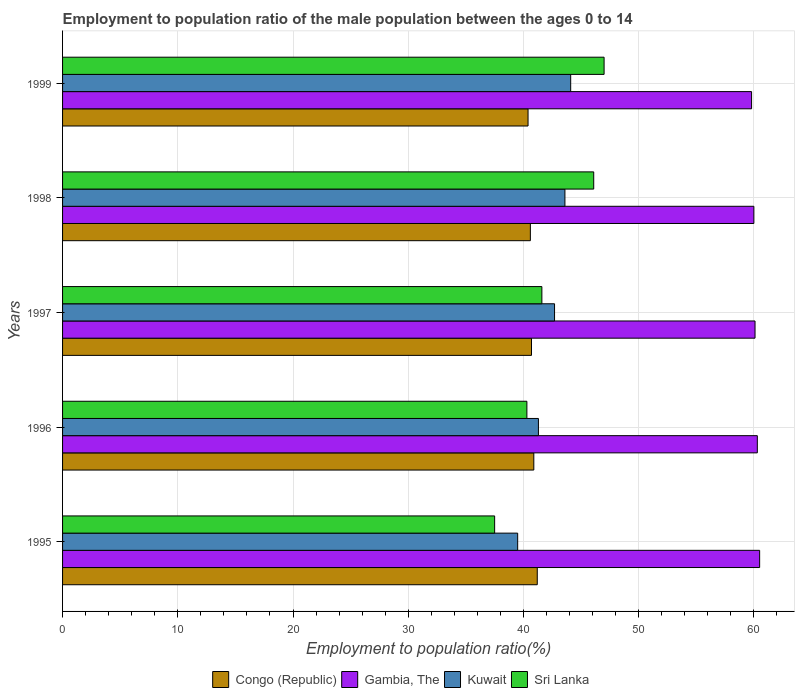How many different coloured bars are there?
Provide a succinct answer. 4. How many groups of bars are there?
Your answer should be very brief. 5. Are the number of bars per tick equal to the number of legend labels?
Your answer should be compact. Yes. Are the number of bars on each tick of the Y-axis equal?
Keep it short and to the point. Yes. How many bars are there on the 5th tick from the bottom?
Offer a very short reply. 4. What is the employment to population ratio in Congo (Republic) in 1998?
Your answer should be compact. 40.6. Across all years, what is the maximum employment to population ratio in Congo (Republic)?
Provide a succinct answer. 41.2. Across all years, what is the minimum employment to population ratio in Congo (Republic)?
Give a very brief answer. 40.4. In which year was the employment to population ratio in Sri Lanka maximum?
Keep it short and to the point. 1999. What is the total employment to population ratio in Kuwait in the graph?
Offer a very short reply. 211.2. What is the difference between the employment to population ratio in Kuwait in 1998 and the employment to population ratio in Congo (Republic) in 1995?
Your answer should be very brief. 2.4. What is the average employment to population ratio in Gambia, The per year?
Offer a very short reply. 60.14. In the year 1996, what is the difference between the employment to population ratio in Congo (Republic) and employment to population ratio in Sri Lanka?
Provide a succinct answer. 0.6. In how many years, is the employment to population ratio in Sri Lanka greater than 16 %?
Make the answer very short. 5. What is the ratio of the employment to population ratio in Sri Lanka in 1995 to that in 1996?
Your answer should be very brief. 0.93. Is the employment to population ratio in Sri Lanka in 1997 less than that in 1998?
Your answer should be compact. Yes. What is the difference between the highest and the second highest employment to population ratio in Congo (Republic)?
Offer a terse response. 0.3. What does the 4th bar from the top in 1995 represents?
Your answer should be compact. Congo (Republic). What does the 3rd bar from the bottom in 1996 represents?
Give a very brief answer. Kuwait. Is it the case that in every year, the sum of the employment to population ratio in Congo (Republic) and employment to population ratio in Gambia, The is greater than the employment to population ratio in Kuwait?
Provide a succinct answer. Yes. How many bars are there?
Offer a terse response. 20. What is the difference between two consecutive major ticks on the X-axis?
Offer a very short reply. 10. Are the values on the major ticks of X-axis written in scientific E-notation?
Give a very brief answer. No. Does the graph contain grids?
Offer a very short reply. Yes. Where does the legend appear in the graph?
Your answer should be compact. Bottom center. What is the title of the graph?
Your answer should be compact. Employment to population ratio of the male population between the ages 0 to 14. What is the label or title of the X-axis?
Ensure brevity in your answer.  Employment to population ratio(%). What is the Employment to population ratio(%) of Congo (Republic) in 1995?
Ensure brevity in your answer.  41.2. What is the Employment to population ratio(%) in Gambia, The in 1995?
Your response must be concise. 60.5. What is the Employment to population ratio(%) in Kuwait in 1995?
Offer a terse response. 39.5. What is the Employment to population ratio(%) in Sri Lanka in 1995?
Your response must be concise. 37.5. What is the Employment to population ratio(%) in Congo (Republic) in 1996?
Your response must be concise. 40.9. What is the Employment to population ratio(%) of Gambia, The in 1996?
Your answer should be compact. 60.3. What is the Employment to population ratio(%) of Kuwait in 1996?
Offer a terse response. 41.3. What is the Employment to population ratio(%) of Sri Lanka in 1996?
Offer a terse response. 40.3. What is the Employment to population ratio(%) of Congo (Republic) in 1997?
Offer a very short reply. 40.7. What is the Employment to population ratio(%) of Gambia, The in 1997?
Your answer should be very brief. 60.1. What is the Employment to population ratio(%) in Kuwait in 1997?
Offer a terse response. 42.7. What is the Employment to population ratio(%) in Sri Lanka in 1997?
Your response must be concise. 41.6. What is the Employment to population ratio(%) of Congo (Republic) in 1998?
Offer a very short reply. 40.6. What is the Employment to population ratio(%) in Kuwait in 1998?
Make the answer very short. 43.6. What is the Employment to population ratio(%) in Sri Lanka in 1998?
Your answer should be very brief. 46.1. What is the Employment to population ratio(%) of Congo (Republic) in 1999?
Your answer should be very brief. 40.4. What is the Employment to population ratio(%) in Gambia, The in 1999?
Your answer should be very brief. 59.8. What is the Employment to population ratio(%) in Kuwait in 1999?
Your answer should be very brief. 44.1. Across all years, what is the maximum Employment to population ratio(%) in Congo (Republic)?
Your answer should be very brief. 41.2. Across all years, what is the maximum Employment to population ratio(%) of Gambia, The?
Give a very brief answer. 60.5. Across all years, what is the maximum Employment to population ratio(%) of Kuwait?
Your answer should be very brief. 44.1. Across all years, what is the minimum Employment to population ratio(%) of Congo (Republic)?
Keep it short and to the point. 40.4. Across all years, what is the minimum Employment to population ratio(%) in Gambia, The?
Provide a succinct answer. 59.8. Across all years, what is the minimum Employment to population ratio(%) in Kuwait?
Offer a very short reply. 39.5. Across all years, what is the minimum Employment to population ratio(%) in Sri Lanka?
Your response must be concise. 37.5. What is the total Employment to population ratio(%) of Congo (Republic) in the graph?
Your answer should be compact. 203.8. What is the total Employment to population ratio(%) of Gambia, The in the graph?
Offer a terse response. 300.7. What is the total Employment to population ratio(%) of Kuwait in the graph?
Give a very brief answer. 211.2. What is the total Employment to population ratio(%) of Sri Lanka in the graph?
Give a very brief answer. 212.5. What is the difference between the Employment to population ratio(%) in Gambia, The in 1995 and that in 1996?
Ensure brevity in your answer.  0.2. What is the difference between the Employment to population ratio(%) in Kuwait in 1995 and that in 1996?
Make the answer very short. -1.8. What is the difference between the Employment to population ratio(%) of Congo (Republic) in 1995 and that in 1997?
Your answer should be very brief. 0.5. What is the difference between the Employment to population ratio(%) of Kuwait in 1995 and that in 1997?
Offer a terse response. -3.2. What is the difference between the Employment to population ratio(%) in Congo (Republic) in 1995 and that in 1998?
Your answer should be compact. 0.6. What is the difference between the Employment to population ratio(%) of Sri Lanka in 1995 and that in 1999?
Provide a short and direct response. -9.5. What is the difference between the Employment to population ratio(%) of Congo (Republic) in 1996 and that in 1997?
Your answer should be compact. 0.2. What is the difference between the Employment to population ratio(%) in Sri Lanka in 1996 and that in 1997?
Make the answer very short. -1.3. What is the difference between the Employment to population ratio(%) of Congo (Republic) in 1996 and that in 1998?
Provide a succinct answer. 0.3. What is the difference between the Employment to population ratio(%) of Sri Lanka in 1996 and that in 1998?
Offer a terse response. -5.8. What is the difference between the Employment to population ratio(%) in Congo (Republic) in 1996 and that in 1999?
Offer a very short reply. 0.5. What is the difference between the Employment to population ratio(%) of Gambia, The in 1996 and that in 1999?
Your answer should be very brief. 0.5. What is the difference between the Employment to population ratio(%) in Kuwait in 1996 and that in 1999?
Provide a succinct answer. -2.8. What is the difference between the Employment to population ratio(%) of Sri Lanka in 1996 and that in 1999?
Make the answer very short. -6.7. What is the difference between the Employment to population ratio(%) of Kuwait in 1997 and that in 1998?
Your response must be concise. -0.9. What is the difference between the Employment to population ratio(%) in Gambia, The in 1997 and that in 1999?
Provide a succinct answer. 0.3. What is the difference between the Employment to population ratio(%) in Kuwait in 1997 and that in 1999?
Ensure brevity in your answer.  -1.4. What is the difference between the Employment to population ratio(%) of Congo (Republic) in 1998 and that in 1999?
Ensure brevity in your answer.  0.2. What is the difference between the Employment to population ratio(%) of Sri Lanka in 1998 and that in 1999?
Provide a short and direct response. -0.9. What is the difference between the Employment to population ratio(%) of Congo (Republic) in 1995 and the Employment to population ratio(%) of Gambia, The in 1996?
Your answer should be compact. -19.1. What is the difference between the Employment to population ratio(%) in Congo (Republic) in 1995 and the Employment to population ratio(%) in Kuwait in 1996?
Ensure brevity in your answer.  -0.1. What is the difference between the Employment to population ratio(%) of Gambia, The in 1995 and the Employment to population ratio(%) of Sri Lanka in 1996?
Your answer should be very brief. 20.2. What is the difference between the Employment to population ratio(%) in Kuwait in 1995 and the Employment to population ratio(%) in Sri Lanka in 1996?
Give a very brief answer. -0.8. What is the difference between the Employment to population ratio(%) in Congo (Republic) in 1995 and the Employment to population ratio(%) in Gambia, The in 1997?
Your answer should be compact. -18.9. What is the difference between the Employment to population ratio(%) of Congo (Republic) in 1995 and the Employment to population ratio(%) of Kuwait in 1997?
Make the answer very short. -1.5. What is the difference between the Employment to population ratio(%) of Congo (Republic) in 1995 and the Employment to population ratio(%) of Sri Lanka in 1997?
Give a very brief answer. -0.4. What is the difference between the Employment to population ratio(%) in Gambia, The in 1995 and the Employment to population ratio(%) in Kuwait in 1997?
Offer a terse response. 17.8. What is the difference between the Employment to population ratio(%) in Congo (Republic) in 1995 and the Employment to population ratio(%) in Gambia, The in 1998?
Provide a succinct answer. -18.8. What is the difference between the Employment to population ratio(%) of Congo (Republic) in 1995 and the Employment to population ratio(%) of Sri Lanka in 1998?
Provide a short and direct response. -4.9. What is the difference between the Employment to population ratio(%) in Kuwait in 1995 and the Employment to population ratio(%) in Sri Lanka in 1998?
Provide a succinct answer. -6.6. What is the difference between the Employment to population ratio(%) in Congo (Republic) in 1995 and the Employment to population ratio(%) in Gambia, The in 1999?
Offer a very short reply. -18.6. What is the difference between the Employment to population ratio(%) in Congo (Republic) in 1996 and the Employment to population ratio(%) in Gambia, The in 1997?
Keep it short and to the point. -19.2. What is the difference between the Employment to population ratio(%) in Congo (Republic) in 1996 and the Employment to population ratio(%) in Gambia, The in 1998?
Keep it short and to the point. -19.1. What is the difference between the Employment to population ratio(%) in Congo (Republic) in 1996 and the Employment to population ratio(%) in Kuwait in 1998?
Your response must be concise. -2.7. What is the difference between the Employment to population ratio(%) in Congo (Republic) in 1996 and the Employment to population ratio(%) in Sri Lanka in 1998?
Your response must be concise. -5.2. What is the difference between the Employment to population ratio(%) in Gambia, The in 1996 and the Employment to population ratio(%) in Kuwait in 1998?
Keep it short and to the point. 16.7. What is the difference between the Employment to population ratio(%) of Congo (Republic) in 1996 and the Employment to population ratio(%) of Gambia, The in 1999?
Offer a very short reply. -18.9. What is the difference between the Employment to population ratio(%) of Congo (Republic) in 1996 and the Employment to population ratio(%) of Kuwait in 1999?
Provide a succinct answer. -3.2. What is the difference between the Employment to population ratio(%) in Congo (Republic) in 1996 and the Employment to population ratio(%) in Sri Lanka in 1999?
Make the answer very short. -6.1. What is the difference between the Employment to population ratio(%) of Congo (Republic) in 1997 and the Employment to population ratio(%) of Gambia, The in 1998?
Give a very brief answer. -19.3. What is the difference between the Employment to population ratio(%) in Congo (Republic) in 1997 and the Employment to population ratio(%) in Kuwait in 1998?
Your response must be concise. -2.9. What is the difference between the Employment to population ratio(%) of Congo (Republic) in 1997 and the Employment to population ratio(%) of Sri Lanka in 1998?
Your response must be concise. -5.4. What is the difference between the Employment to population ratio(%) in Congo (Republic) in 1997 and the Employment to population ratio(%) in Gambia, The in 1999?
Make the answer very short. -19.1. What is the difference between the Employment to population ratio(%) of Gambia, The in 1997 and the Employment to population ratio(%) of Kuwait in 1999?
Provide a succinct answer. 16. What is the difference between the Employment to population ratio(%) in Gambia, The in 1997 and the Employment to population ratio(%) in Sri Lanka in 1999?
Provide a short and direct response. 13.1. What is the difference between the Employment to population ratio(%) in Congo (Republic) in 1998 and the Employment to population ratio(%) in Gambia, The in 1999?
Give a very brief answer. -19.2. What is the difference between the Employment to population ratio(%) of Kuwait in 1998 and the Employment to population ratio(%) of Sri Lanka in 1999?
Offer a very short reply. -3.4. What is the average Employment to population ratio(%) of Congo (Republic) per year?
Give a very brief answer. 40.76. What is the average Employment to population ratio(%) of Gambia, The per year?
Ensure brevity in your answer.  60.14. What is the average Employment to population ratio(%) in Kuwait per year?
Ensure brevity in your answer.  42.24. What is the average Employment to population ratio(%) of Sri Lanka per year?
Ensure brevity in your answer.  42.5. In the year 1995, what is the difference between the Employment to population ratio(%) in Congo (Republic) and Employment to population ratio(%) in Gambia, The?
Your answer should be very brief. -19.3. In the year 1995, what is the difference between the Employment to population ratio(%) in Congo (Republic) and Employment to population ratio(%) in Kuwait?
Provide a short and direct response. 1.7. In the year 1995, what is the difference between the Employment to population ratio(%) in Kuwait and Employment to population ratio(%) in Sri Lanka?
Your answer should be compact. 2. In the year 1996, what is the difference between the Employment to population ratio(%) in Congo (Republic) and Employment to population ratio(%) in Gambia, The?
Keep it short and to the point. -19.4. In the year 1996, what is the difference between the Employment to population ratio(%) in Congo (Republic) and Employment to population ratio(%) in Kuwait?
Your answer should be very brief. -0.4. In the year 1996, what is the difference between the Employment to population ratio(%) of Gambia, The and Employment to population ratio(%) of Kuwait?
Offer a very short reply. 19. In the year 1996, what is the difference between the Employment to population ratio(%) of Gambia, The and Employment to population ratio(%) of Sri Lanka?
Make the answer very short. 20. In the year 1996, what is the difference between the Employment to population ratio(%) of Kuwait and Employment to population ratio(%) of Sri Lanka?
Offer a terse response. 1. In the year 1997, what is the difference between the Employment to population ratio(%) of Congo (Republic) and Employment to population ratio(%) of Gambia, The?
Your answer should be very brief. -19.4. In the year 1997, what is the difference between the Employment to population ratio(%) of Congo (Republic) and Employment to population ratio(%) of Sri Lanka?
Offer a very short reply. -0.9. In the year 1997, what is the difference between the Employment to population ratio(%) in Gambia, The and Employment to population ratio(%) in Kuwait?
Your answer should be very brief. 17.4. In the year 1997, what is the difference between the Employment to population ratio(%) in Gambia, The and Employment to population ratio(%) in Sri Lanka?
Offer a terse response. 18.5. In the year 1997, what is the difference between the Employment to population ratio(%) in Kuwait and Employment to population ratio(%) in Sri Lanka?
Offer a very short reply. 1.1. In the year 1998, what is the difference between the Employment to population ratio(%) in Congo (Republic) and Employment to population ratio(%) in Gambia, The?
Offer a very short reply. -19.4. In the year 1998, what is the difference between the Employment to population ratio(%) in Gambia, The and Employment to population ratio(%) in Sri Lanka?
Offer a terse response. 13.9. In the year 1998, what is the difference between the Employment to population ratio(%) in Kuwait and Employment to population ratio(%) in Sri Lanka?
Offer a very short reply. -2.5. In the year 1999, what is the difference between the Employment to population ratio(%) in Congo (Republic) and Employment to population ratio(%) in Gambia, The?
Offer a very short reply. -19.4. In the year 1999, what is the difference between the Employment to population ratio(%) of Congo (Republic) and Employment to population ratio(%) of Sri Lanka?
Your response must be concise. -6.6. In the year 1999, what is the difference between the Employment to population ratio(%) of Gambia, The and Employment to population ratio(%) of Kuwait?
Offer a terse response. 15.7. What is the ratio of the Employment to population ratio(%) in Congo (Republic) in 1995 to that in 1996?
Keep it short and to the point. 1.01. What is the ratio of the Employment to population ratio(%) of Gambia, The in 1995 to that in 1996?
Make the answer very short. 1. What is the ratio of the Employment to population ratio(%) in Kuwait in 1995 to that in 1996?
Your answer should be very brief. 0.96. What is the ratio of the Employment to population ratio(%) of Sri Lanka in 1995 to that in 1996?
Provide a succinct answer. 0.93. What is the ratio of the Employment to population ratio(%) of Congo (Republic) in 1995 to that in 1997?
Your answer should be compact. 1.01. What is the ratio of the Employment to population ratio(%) of Gambia, The in 1995 to that in 1997?
Ensure brevity in your answer.  1.01. What is the ratio of the Employment to population ratio(%) in Kuwait in 1995 to that in 1997?
Provide a succinct answer. 0.93. What is the ratio of the Employment to population ratio(%) in Sri Lanka in 1995 to that in 1997?
Your answer should be very brief. 0.9. What is the ratio of the Employment to population ratio(%) of Congo (Republic) in 1995 to that in 1998?
Offer a terse response. 1.01. What is the ratio of the Employment to population ratio(%) in Gambia, The in 1995 to that in 1998?
Provide a short and direct response. 1.01. What is the ratio of the Employment to population ratio(%) in Kuwait in 1995 to that in 1998?
Provide a short and direct response. 0.91. What is the ratio of the Employment to population ratio(%) in Sri Lanka in 1995 to that in 1998?
Your answer should be compact. 0.81. What is the ratio of the Employment to population ratio(%) in Congo (Republic) in 1995 to that in 1999?
Ensure brevity in your answer.  1.02. What is the ratio of the Employment to population ratio(%) in Gambia, The in 1995 to that in 1999?
Provide a succinct answer. 1.01. What is the ratio of the Employment to population ratio(%) in Kuwait in 1995 to that in 1999?
Provide a short and direct response. 0.9. What is the ratio of the Employment to population ratio(%) of Sri Lanka in 1995 to that in 1999?
Give a very brief answer. 0.8. What is the ratio of the Employment to population ratio(%) in Congo (Republic) in 1996 to that in 1997?
Ensure brevity in your answer.  1. What is the ratio of the Employment to population ratio(%) of Gambia, The in 1996 to that in 1997?
Keep it short and to the point. 1. What is the ratio of the Employment to population ratio(%) of Kuwait in 1996 to that in 1997?
Your answer should be compact. 0.97. What is the ratio of the Employment to population ratio(%) of Sri Lanka in 1996 to that in 1997?
Ensure brevity in your answer.  0.97. What is the ratio of the Employment to population ratio(%) of Congo (Republic) in 1996 to that in 1998?
Provide a succinct answer. 1.01. What is the ratio of the Employment to population ratio(%) of Gambia, The in 1996 to that in 1998?
Ensure brevity in your answer.  1. What is the ratio of the Employment to population ratio(%) of Kuwait in 1996 to that in 1998?
Your response must be concise. 0.95. What is the ratio of the Employment to population ratio(%) in Sri Lanka in 1996 to that in 1998?
Offer a terse response. 0.87. What is the ratio of the Employment to population ratio(%) of Congo (Republic) in 1996 to that in 1999?
Give a very brief answer. 1.01. What is the ratio of the Employment to population ratio(%) in Gambia, The in 1996 to that in 1999?
Make the answer very short. 1.01. What is the ratio of the Employment to population ratio(%) of Kuwait in 1996 to that in 1999?
Offer a terse response. 0.94. What is the ratio of the Employment to population ratio(%) of Sri Lanka in 1996 to that in 1999?
Your answer should be compact. 0.86. What is the ratio of the Employment to population ratio(%) of Congo (Republic) in 1997 to that in 1998?
Keep it short and to the point. 1. What is the ratio of the Employment to population ratio(%) of Gambia, The in 1997 to that in 1998?
Offer a very short reply. 1. What is the ratio of the Employment to population ratio(%) of Kuwait in 1997 to that in 1998?
Your answer should be very brief. 0.98. What is the ratio of the Employment to population ratio(%) of Sri Lanka in 1997 to that in 1998?
Your answer should be compact. 0.9. What is the ratio of the Employment to population ratio(%) of Congo (Republic) in 1997 to that in 1999?
Offer a very short reply. 1.01. What is the ratio of the Employment to population ratio(%) in Kuwait in 1997 to that in 1999?
Your response must be concise. 0.97. What is the ratio of the Employment to population ratio(%) in Sri Lanka in 1997 to that in 1999?
Provide a short and direct response. 0.89. What is the ratio of the Employment to population ratio(%) of Congo (Republic) in 1998 to that in 1999?
Provide a short and direct response. 1. What is the ratio of the Employment to population ratio(%) of Kuwait in 1998 to that in 1999?
Keep it short and to the point. 0.99. What is the ratio of the Employment to population ratio(%) of Sri Lanka in 1998 to that in 1999?
Offer a very short reply. 0.98. What is the difference between the highest and the second highest Employment to population ratio(%) of Gambia, The?
Offer a very short reply. 0.2. What is the difference between the highest and the second highest Employment to population ratio(%) in Kuwait?
Provide a succinct answer. 0.5. What is the difference between the highest and the lowest Employment to population ratio(%) of Gambia, The?
Offer a terse response. 0.7. What is the difference between the highest and the lowest Employment to population ratio(%) of Kuwait?
Your response must be concise. 4.6. What is the difference between the highest and the lowest Employment to population ratio(%) of Sri Lanka?
Ensure brevity in your answer.  9.5. 